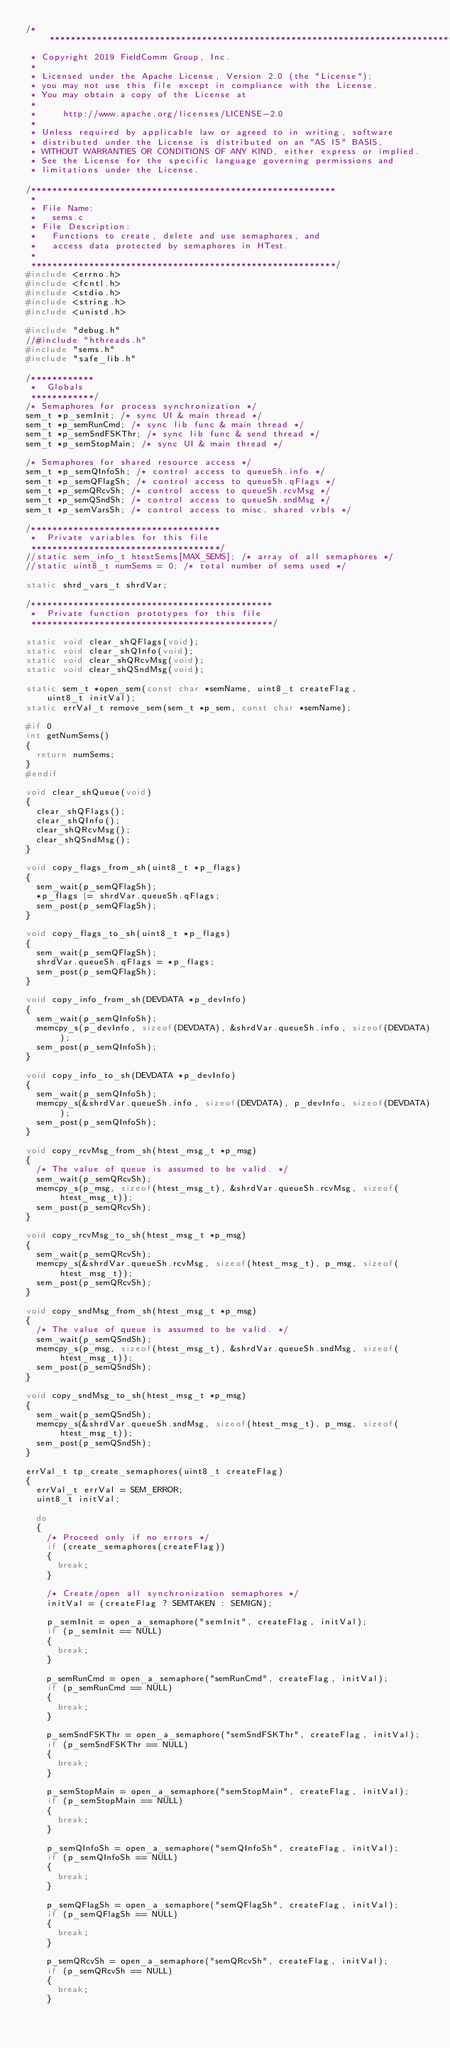Convert code to text. <code><loc_0><loc_0><loc_500><loc_500><_C++_>/*************************************************************************************************
 * Copyright 2019 FieldComm Group, Inc.
 *
 * Licensed under the Apache License, Version 2.0 (the "License");
 * you may not use this file except in compliance with the License.
 * You may obtain a copy of the License at
 *
 *     http://www.apache.org/licenses/LICENSE-2.0
 *
 * Unless required by applicable law or agreed to in writing, software
 * distributed under the License is distributed on an "AS IS" BASIS,
 * WITHOUT WARRANTIES OR CONDITIONS OF ANY KIND, either express or implied.
 * See the License for the specific language governing permissions and
 * limitations under the License.

/**********************************************************
 *
 * File Name:
 *   sems.c
 * File Description:
 *   Functions to create, delete and use semaphores, and
 *   access data protected by semaphores in HTest.
 *
 **********************************************************/
#include <errno.h>
#include <fcntl.h>
#include <stdio.h>
#include <string.h>        
#include <unistd.h>

#include "debug.h"
//#include "hthreads.h"
#include "sems.h"
#include "safe_lib.h"

/************
 *  Globals
 ************/
/* Semaphores for process synchronization */
sem_t *p_semInit; /* sync UI & main thread */
sem_t *p_semRunCmd; /* sync lib func & main thread */
sem_t *p_semSndFSKThr; /* sync lib func & send thread */
sem_t *p_semStopMain; /* sync UI & main thread */

/* Semaphores for shared resource access */
sem_t *p_semQInfoSh; /* control access to queueSh.info */
sem_t *p_semQFlagSh; /* control access to queueSh.qFlags */
sem_t *p_semQRcvSh; /* control access to queueSh.rcvMsg */
sem_t *p_semQSndSh; /* control access to queueSh.sndMsg */
sem_t *p_semVarsSh; /* control access to misc. shared vrbls */

/************************************
 *  Private variables for this file  
 ************************************/
//static sem_info_t htestSems[MAX_SEMS]; /* array of all semaphores */
//static uint8_t numSems = 0; /* total number of sems used */

static shrd_vars_t shrdVar;

/**********************************************
 *  Private function prototypes for this file
 **********************************************/

static void clear_shQFlags(void);
static void clear_shQInfo(void);
static void clear_shQRcvMsg(void);
static void clear_shQSndMsg(void);

static sem_t *open_sem(const char *semName, uint8_t createFlag,
		uint8_t initVal);
static errVal_t remove_sem(sem_t *p_sem, const char *semName);

#if 0
int getNumSems()
{
	return numSems;
}
#endif

void clear_shQueue(void)
{
	clear_shQFlags();
	clear_shQInfo();
	clear_shQRcvMsg();
	clear_shQSndMsg();
}

void copy_flags_from_sh(uint8_t *p_flags)
{
	sem_wait(p_semQFlagSh);
	*p_flags |= shrdVar.queueSh.qFlags;
	sem_post(p_semQFlagSh);
}

void copy_flags_to_sh(uint8_t *p_flags)
{
	sem_wait(p_semQFlagSh);
	shrdVar.queueSh.qFlags = *p_flags;
	sem_post(p_semQFlagSh);
}

void copy_info_from_sh(DEVDATA *p_devInfo)
{
	sem_wait(p_semQInfoSh);
	memcpy_s(p_devInfo, sizeof(DEVDATA), &shrdVar.queueSh.info, sizeof(DEVDATA));
	sem_post(p_semQInfoSh);
}

void copy_info_to_sh(DEVDATA *p_devInfo)
{
	sem_wait(p_semQInfoSh);
	memcpy_s(&shrdVar.queueSh.info, sizeof(DEVDATA), p_devInfo, sizeof(DEVDATA));
	sem_post(p_semQInfoSh);
}

void copy_rcvMsg_from_sh(htest_msg_t *p_msg)
{
	/* The value of queue is assumed to be valid. */
	sem_wait(p_semQRcvSh);
	memcpy_s(p_msg, sizeof(htest_msg_t), &shrdVar.queueSh.rcvMsg, sizeof(htest_msg_t));
	sem_post(p_semQRcvSh);
}

void copy_rcvMsg_to_sh(htest_msg_t *p_msg)
{
	sem_wait(p_semQRcvSh);
	memcpy_s(&shrdVar.queueSh.rcvMsg, sizeof(htest_msg_t), p_msg, sizeof(htest_msg_t));
	sem_post(p_semQRcvSh);
}

void copy_sndMsg_from_sh(htest_msg_t *p_msg)
{
	/* The value of queue is assumed to be valid. */
	sem_wait(p_semQSndSh);
	memcpy_s(p_msg, sizeof(htest_msg_t), &shrdVar.queueSh.sndMsg, sizeof(htest_msg_t));
	sem_post(p_semQSndSh);
}

void copy_sndMsg_to_sh(htest_msg_t *p_msg)
{
	sem_wait(p_semQSndSh);
	memcpy_s(&shrdVar.queueSh.sndMsg, sizeof(htest_msg_t), p_msg, sizeof(htest_msg_t));
	sem_post(p_semQSndSh);
}

errVal_t tp_create_semaphores(uint8_t createFlag)
{
	errVal_t errVal = SEM_ERROR;
	uint8_t initVal;

	do
	{
		/* Proceed only if no errors */
		if (create_semaphores(createFlag))
		{
			break;
		}

		/* Create/open all synchronization semaphores */
		initVal = (createFlag ? SEMTAKEN : SEMIGN);

		p_semInit = open_a_semaphore("semInit", createFlag, initVal);
		if (p_semInit == NULL)
		{
			break;
		}

		p_semRunCmd = open_a_semaphore("semRunCmd", createFlag, initVal);
		if (p_semRunCmd == NULL)
		{
			break;
		}

		p_semSndFSKThr = open_a_semaphore("semSndFSKThr", createFlag, initVal);
		if (p_semSndFSKThr == NULL)
		{
			break;
		}

		p_semStopMain = open_a_semaphore("semStopMain", createFlag, initVal);
		if (p_semStopMain == NULL)
		{
			break;
		}

		p_semQInfoSh = open_a_semaphore("semQInfoSh", createFlag, initVal);
		if (p_semQInfoSh == NULL)
		{
			break;
		}

		p_semQFlagSh = open_a_semaphore("semQFlagSh", createFlag, initVal);
		if (p_semQFlagSh == NULL)
		{
			break;
		}

		p_semQRcvSh = open_a_semaphore("semQRcvSh", createFlag, initVal);
		if (p_semQRcvSh == NULL)
		{
			break;
		}
</code> 